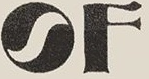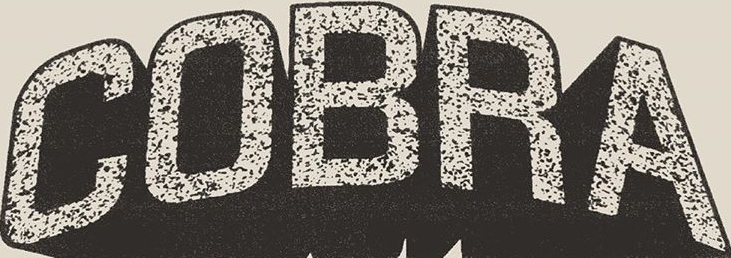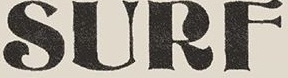Read the text from these images in sequence, separated by a semicolon. OF; COBRA; SURF 